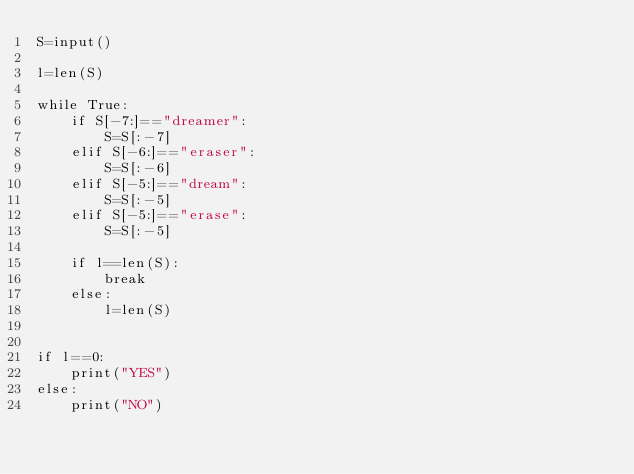<code> <loc_0><loc_0><loc_500><loc_500><_Python_>S=input()

l=len(S)

while True:
    if S[-7:]=="dreamer":
        S=S[:-7] 
    elif S[-6:]=="eraser":
        S=S[:-6]
    elif S[-5:]=="dream":
        S=S[:-5]
    elif S[-5:]=="erase":
        S=S[:-5]

    if l==len(S):
        break
    else:
        l=len(S)


if l==0:
    print("YES")
else:
    print("NO")</code> 